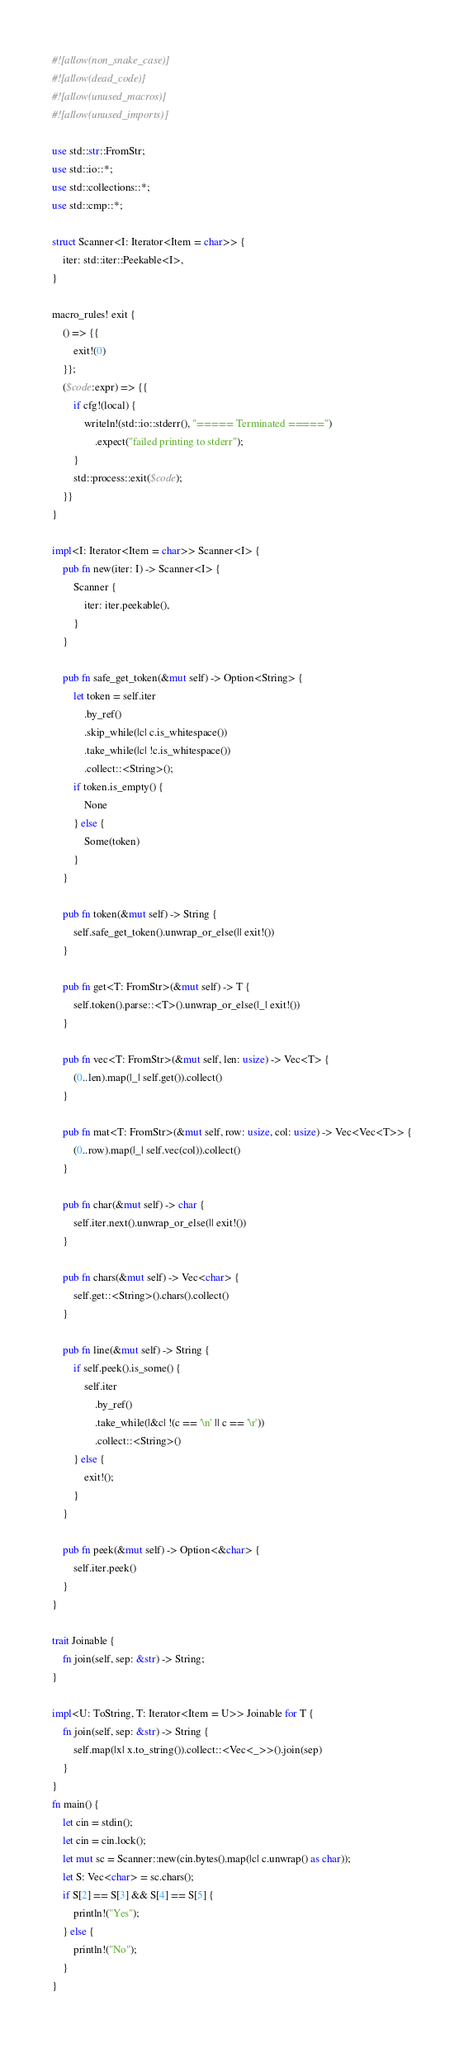Convert code to text. <code><loc_0><loc_0><loc_500><loc_500><_Rust_>#![allow(non_snake_case)]
#![allow(dead_code)]
#![allow(unused_macros)]
#![allow(unused_imports)]

use std::str::FromStr;
use std::io::*;
use std::collections::*;
use std::cmp::*;

struct Scanner<I: Iterator<Item = char>> {
    iter: std::iter::Peekable<I>,
}

macro_rules! exit {
    () => {{
        exit!(0)
    }};
    ($code:expr) => {{
        if cfg!(local) {
            writeln!(std::io::stderr(), "===== Terminated =====")
                .expect("failed printing to stderr");
        }
        std::process::exit($code);
    }}
}

impl<I: Iterator<Item = char>> Scanner<I> {
    pub fn new(iter: I) -> Scanner<I> {
        Scanner {
            iter: iter.peekable(),
        }
    }

    pub fn safe_get_token(&mut self) -> Option<String> {
        let token = self.iter
            .by_ref()
            .skip_while(|c| c.is_whitespace())
            .take_while(|c| !c.is_whitespace())
            .collect::<String>();
        if token.is_empty() {
            None
        } else {
            Some(token)
        }
    }

    pub fn token(&mut self) -> String {
        self.safe_get_token().unwrap_or_else(|| exit!())
    }

    pub fn get<T: FromStr>(&mut self) -> T {
        self.token().parse::<T>().unwrap_or_else(|_| exit!())
    }

    pub fn vec<T: FromStr>(&mut self, len: usize) -> Vec<T> {
        (0..len).map(|_| self.get()).collect()
    }

    pub fn mat<T: FromStr>(&mut self, row: usize, col: usize) -> Vec<Vec<T>> {
        (0..row).map(|_| self.vec(col)).collect()
    }

    pub fn char(&mut self) -> char {
        self.iter.next().unwrap_or_else(|| exit!())
    }

    pub fn chars(&mut self) -> Vec<char> {
        self.get::<String>().chars().collect()
    }

    pub fn line(&mut self) -> String {
        if self.peek().is_some() {
            self.iter
                .by_ref()
                .take_while(|&c| !(c == '\n' || c == '\r'))
                .collect::<String>()
        } else {
            exit!();
        }
    }

    pub fn peek(&mut self) -> Option<&char> {
        self.iter.peek()
    }
}

trait Joinable {
    fn join(self, sep: &str) -> String;
}

impl<U: ToString, T: Iterator<Item = U>> Joinable for T {
    fn join(self, sep: &str) -> String {
        self.map(|x| x.to_string()).collect::<Vec<_>>().join(sep)
    }
}
fn main() {
    let cin = stdin();
    let cin = cin.lock();
    let mut sc = Scanner::new(cin.bytes().map(|c| c.unwrap() as char));
    let S: Vec<char> = sc.chars();
    if S[2] == S[3] && S[4] == S[5] {
        println!("Yes");
    } else {
        println!("No");
    }
}
</code> 